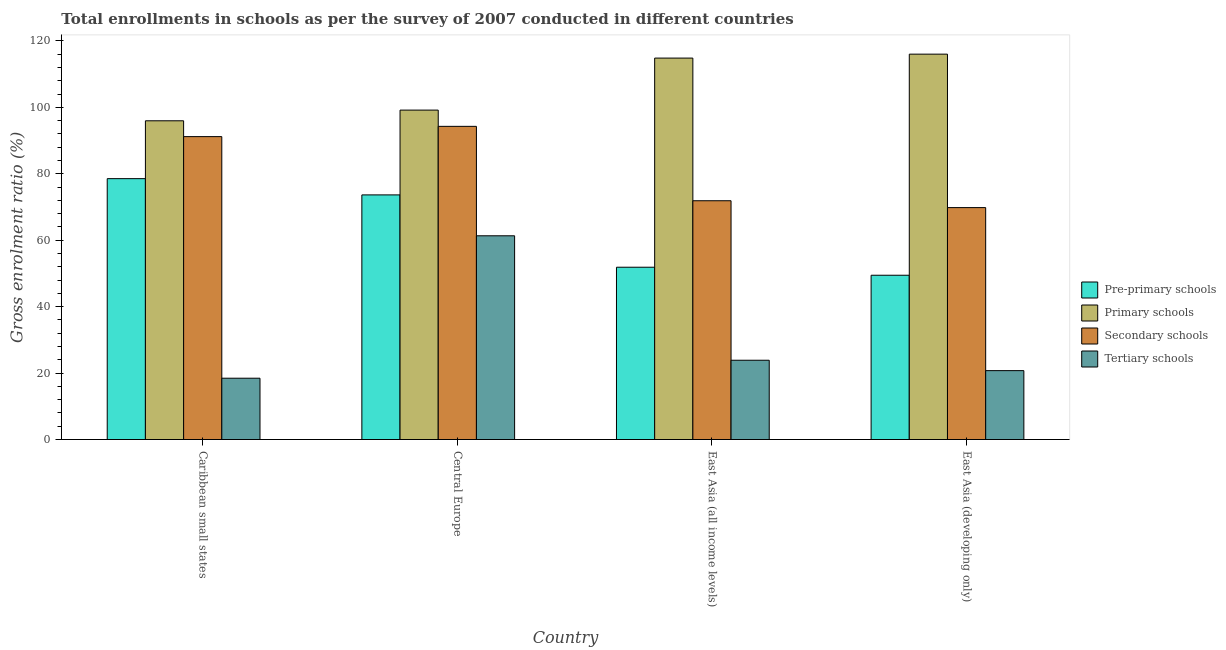How many groups of bars are there?
Ensure brevity in your answer.  4. How many bars are there on the 4th tick from the left?
Offer a terse response. 4. How many bars are there on the 2nd tick from the right?
Your answer should be compact. 4. What is the label of the 4th group of bars from the left?
Offer a terse response. East Asia (developing only). In how many cases, is the number of bars for a given country not equal to the number of legend labels?
Your answer should be very brief. 0. What is the gross enrolment ratio in primary schools in Central Europe?
Your answer should be compact. 99.16. Across all countries, what is the maximum gross enrolment ratio in secondary schools?
Make the answer very short. 94.27. Across all countries, what is the minimum gross enrolment ratio in tertiary schools?
Provide a short and direct response. 18.46. In which country was the gross enrolment ratio in pre-primary schools maximum?
Offer a very short reply. Caribbean small states. In which country was the gross enrolment ratio in pre-primary schools minimum?
Your answer should be compact. East Asia (developing only). What is the total gross enrolment ratio in secondary schools in the graph?
Give a very brief answer. 327.12. What is the difference between the gross enrolment ratio in secondary schools in Caribbean small states and that in East Asia (developing only)?
Provide a short and direct response. 21.37. What is the difference between the gross enrolment ratio in pre-primary schools in East Asia (developing only) and the gross enrolment ratio in tertiary schools in East Asia (all income levels)?
Give a very brief answer. 25.59. What is the average gross enrolment ratio in tertiary schools per country?
Ensure brevity in your answer.  31.1. What is the difference between the gross enrolment ratio in primary schools and gross enrolment ratio in pre-primary schools in Caribbean small states?
Your answer should be very brief. 17.41. In how many countries, is the gross enrolment ratio in secondary schools greater than 64 %?
Your answer should be very brief. 4. What is the ratio of the gross enrolment ratio in tertiary schools in Caribbean small states to that in East Asia (developing only)?
Offer a terse response. 0.89. What is the difference between the highest and the second highest gross enrolment ratio in secondary schools?
Provide a short and direct response. 3.09. What is the difference between the highest and the lowest gross enrolment ratio in primary schools?
Your answer should be very brief. 20.06. What does the 4th bar from the left in East Asia (developing only) represents?
Your response must be concise. Tertiary schools. What does the 4th bar from the right in East Asia (developing only) represents?
Provide a short and direct response. Pre-primary schools. How many bars are there?
Ensure brevity in your answer.  16. How many countries are there in the graph?
Provide a short and direct response. 4. Are the values on the major ticks of Y-axis written in scientific E-notation?
Offer a terse response. No. How many legend labels are there?
Your response must be concise. 4. What is the title of the graph?
Your answer should be compact. Total enrollments in schools as per the survey of 2007 conducted in different countries. What is the label or title of the X-axis?
Provide a succinct answer. Country. What is the label or title of the Y-axis?
Offer a very short reply. Gross enrolment ratio (%). What is the Gross enrolment ratio (%) in Pre-primary schools in Caribbean small states?
Give a very brief answer. 78.53. What is the Gross enrolment ratio (%) in Primary schools in Caribbean small states?
Give a very brief answer. 95.94. What is the Gross enrolment ratio (%) in Secondary schools in Caribbean small states?
Give a very brief answer. 91.18. What is the Gross enrolment ratio (%) of Tertiary schools in Caribbean small states?
Ensure brevity in your answer.  18.46. What is the Gross enrolment ratio (%) of Pre-primary schools in Central Europe?
Offer a very short reply. 73.64. What is the Gross enrolment ratio (%) in Primary schools in Central Europe?
Ensure brevity in your answer.  99.16. What is the Gross enrolment ratio (%) in Secondary schools in Central Europe?
Your answer should be very brief. 94.27. What is the Gross enrolment ratio (%) of Tertiary schools in Central Europe?
Ensure brevity in your answer.  61.33. What is the Gross enrolment ratio (%) of Pre-primary schools in East Asia (all income levels)?
Provide a short and direct response. 51.86. What is the Gross enrolment ratio (%) in Primary schools in East Asia (all income levels)?
Keep it short and to the point. 114.82. What is the Gross enrolment ratio (%) in Secondary schools in East Asia (all income levels)?
Offer a terse response. 71.87. What is the Gross enrolment ratio (%) in Tertiary schools in East Asia (all income levels)?
Your answer should be compact. 23.87. What is the Gross enrolment ratio (%) of Pre-primary schools in East Asia (developing only)?
Offer a terse response. 49.45. What is the Gross enrolment ratio (%) of Primary schools in East Asia (developing only)?
Offer a very short reply. 116. What is the Gross enrolment ratio (%) of Secondary schools in East Asia (developing only)?
Your response must be concise. 69.81. What is the Gross enrolment ratio (%) in Tertiary schools in East Asia (developing only)?
Provide a succinct answer. 20.74. Across all countries, what is the maximum Gross enrolment ratio (%) in Pre-primary schools?
Offer a terse response. 78.53. Across all countries, what is the maximum Gross enrolment ratio (%) in Primary schools?
Offer a very short reply. 116. Across all countries, what is the maximum Gross enrolment ratio (%) in Secondary schools?
Offer a very short reply. 94.27. Across all countries, what is the maximum Gross enrolment ratio (%) in Tertiary schools?
Give a very brief answer. 61.33. Across all countries, what is the minimum Gross enrolment ratio (%) of Pre-primary schools?
Offer a terse response. 49.45. Across all countries, what is the minimum Gross enrolment ratio (%) of Primary schools?
Provide a short and direct response. 95.94. Across all countries, what is the minimum Gross enrolment ratio (%) of Secondary schools?
Your answer should be very brief. 69.81. Across all countries, what is the minimum Gross enrolment ratio (%) in Tertiary schools?
Your response must be concise. 18.46. What is the total Gross enrolment ratio (%) of Pre-primary schools in the graph?
Keep it short and to the point. 253.47. What is the total Gross enrolment ratio (%) of Primary schools in the graph?
Make the answer very short. 425.92. What is the total Gross enrolment ratio (%) in Secondary schools in the graph?
Ensure brevity in your answer.  327.12. What is the total Gross enrolment ratio (%) in Tertiary schools in the graph?
Your answer should be very brief. 124.38. What is the difference between the Gross enrolment ratio (%) of Pre-primary schools in Caribbean small states and that in Central Europe?
Ensure brevity in your answer.  4.89. What is the difference between the Gross enrolment ratio (%) of Primary schools in Caribbean small states and that in Central Europe?
Keep it short and to the point. -3.22. What is the difference between the Gross enrolment ratio (%) of Secondary schools in Caribbean small states and that in Central Europe?
Your answer should be very brief. -3.09. What is the difference between the Gross enrolment ratio (%) of Tertiary schools in Caribbean small states and that in Central Europe?
Make the answer very short. -42.87. What is the difference between the Gross enrolment ratio (%) of Pre-primary schools in Caribbean small states and that in East Asia (all income levels)?
Give a very brief answer. 26.67. What is the difference between the Gross enrolment ratio (%) in Primary schools in Caribbean small states and that in East Asia (all income levels)?
Keep it short and to the point. -18.88. What is the difference between the Gross enrolment ratio (%) of Secondary schools in Caribbean small states and that in East Asia (all income levels)?
Your answer should be very brief. 19.3. What is the difference between the Gross enrolment ratio (%) of Tertiary schools in Caribbean small states and that in East Asia (all income levels)?
Provide a succinct answer. -5.41. What is the difference between the Gross enrolment ratio (%) of Pre-primary schools in Caribbean small states and that in East Asia (developing only)?
Provide a succinct answer. 29.08. What is the difference between the Gross enrolment ratio (%) in Primary schools in Caribbean small states and that in East Asia (developing only)?
Your answer should be compact. -20.06. What is the difference between the Gross enrolment ratio (%) in Secondary schools in Caribbean small states and that in East Asia (developing only)?
Give a very brief answer. 21.37. What is the difference between the Gross enrolment ratio (%) of Tertiary schools in Caribbean small states and that in East Asia (developing only)?
Provide a succinct answer. -2.28. What is the difference between the Gross enrolment ratio (%) in Pre-primary schools in Central Europe and that in East Asia (all income levels)?
Provide a short and direct response. 21.78. What is the difference between the Gross enrolment ratio (%) in Primary schools in Central Europe and that in East Asia (all income levels)?
Offer a terse response. -15.66. What is the difference between the Gross enrolment ratio (%) of Secondary schools in Central Europe and that in East Asia (all income levels)?
Provide a short and direct response. 22.39. What is the difference between the Gross enrolment ratio (%) of Tertiary schools in Central Europe and that in East Asia (all income levels)?
Give a very brief answer. 37.46. What is the difference between the Gross enrolment ratio (%) in Pre-primary schools in Central Europe and that in East Asia (developing only)?
Give a very brief answer. 24.19. What is the difference between the Gross enrolment ratio (%) of Primary schools in Central Europe and that in East Asia (developing only)?
Provide a succinct answer. -16.84. What is the difference between the Gross enrolment ratio (%) in Secondary schools in Central Europe and that in East Asia (developing only)?
Offer a very short reply. 24.46. What is the difference between the Gross enrolment ratio (%) in Tertiary schools in Central Europe and that in East Asia (developing only)?
Your answer should be very brief. 40.59. What is the difference between the Gross enrolment ratio (%) of Pre-primary schools in East Asia (all income levels) and that in East Asia (developing only)?
Ensure brevity in your answer.  2.41. What is the difference between the Gross enrolment ratio (%) in Primary schools in East Asia (all income levels) and that in East Asia (developing only)?
Ensure brevity in your answer.  -1.18. What is the difference between the Gross enrolment ratio (%) in Secondary schools in East Asia (all income levels) and that in East Asia (developing only)?
Offer a terse response. 2.06. What is the difference between the Gross enrolment ratio (%) in Tertiary schools in East Asia (all income levels) and that in East Asia (developing only)?
Keep it short and to the point. 3.13. What is the difference between the Gross enrolment ratio (%) of Pre-primary schools in Caribbean small states and the Gross enrolment ratio (%) of Primary schools in Central Europe?
Offer a very short reply. -20.63. What is the difference between the Gross enrolment ratio (%) in Pre-primary schools in Caribbean small states and the Gross enrolment ratio (%) in Secondary schools in Central Europe?
Provide a succinct answer. -15.74. What is the difference between the Gross enrolment ratio (%) of Pre-primary schools in Caribbean small states and the Gross enrolment ratio (%) of Tertiary schools in Central Europe?
Give a very brief answer. 17.2. What is the difference between the Gross enrolment ratio (%) of Primary schools in Caribbean small states and the Gross enrolment ratio (%) of Secondary schools in Central Europe?
Give a very brief answer. 1.67. What is the difference between the Gross enrolment ratio (%) of Primary schools in Caribbean small states and the Gross enrolment ratio (%) of Tertiary schools in Central Europe?
Provide a short and direct response. 34.61. What is the difference between the Gross enrolment ratio (%) of Secondary schools in Caribbean small states and the Gross enrolment ratio (%) of Tertiary schools in Central Europe?
Provide a short and direct response. 29.85. What is the difference between the Gross enrolment ratio (%) of Pre-primary schools in Caribbean small states and the Gross enrolment ratio (%) of Primary schools in East Asia (all income levels)?
Your answer should be very brief. -36.29. What is the difference between the Gross enrolment ratio (%) of Pre-primary schools in Caribbean small states and the Gross enrolment ratio (%) of Secondary schools in East Asia (all income levels)?
Your answer should be compact. 6.65. What is the difference between the Gross enrolment ratio (%) of Pre-primary schools in Caribbean small states and the Gross enrolment ratio (%) of Tertiary schools in East Asia (all income levels)?
Make the answer very short. 54.66. What is the difference between the Gross enrolment ratio (%) of Primary schools in Caribbean small states and the Gross enrolment ratio (%) of Secondary schools in East Asia (all income levels)?
Make the answer very short. 24.07. What is the difference between the Gross enrolment ratio (%) in Primary schools in Caribbean small states and the Gross enrolment ratio (%) in Tertiary schools in East Asia (all income levels)?
Provide a short and direct response. 72.08. What is the difference between the Gross enrolment ratio (%) in Secondary schools in Caribbean small states and the Gross enrolment ratio (%) in Tertiary schools in East Asia (all income levels)?
Offer a terse response. 67.31. What is the difference between the Gross enrolment ratio (%) of Pre-primary schools in Caribbean small states and the Gross enrolment ratio (%) of Primary schools in East Asia (developing only)?
Provide a succinct answer. -37.48. What is the difference between the Gross enrolment ratio (%) of Pre-primary schools in Caribbean small states and the Gross enrolment ratio (%) of Secondary schools in East Asia (developing only)?
Your response must be concise. 8.72. What is the difference between the Gross enrolment ratio (%) in Pre-primary schools in Caribbean small states and the Gross enrolment ratio (%) in Tertiary schools in East Asia (developing only)?
Your answer should be compact. 57.79. What is the difference between the Gross enrolment ratio (%) in Primary schools in Caribbean small states and the Gross enrolment ratio (%) in Secondary schools in East Asia (developing only)?
Make the answer very short. 26.13. What is the difference between the Gross enrolment ratio (%) in Primary schools in Caribbean small states and the Gross enrolment ratio (%) in Tertiary schools in East Asia (developing only)?
Provide a short and direct response. 75.2. What is the difference between the Gross enrolment ratio (%) of Secondary schools in Caribbean small states and the Gross enrolment ratio (%) of Tertiary schools in East Asia (developing only)?
Provide a short and direct response. 70.44. What is the difference between the Gross enrolment ratio (%) of Pre-primary schools in Central Europe and the Gross enrolment ratio (%) of Primary schools in East Asia (all income levels)?
Your response must be concise. -41.18. What is the difference between the Gross enrolment ratio (%) of Pre-primary schools in Central Europe and the Gross enrolment ratio (%) of Secondary schools in East Asia (all income levels)?
Provide a short and direct response. 1.76. What is the difference between the Gross enrolment ratio (%) in Pre-primary schools in Central Europe and the Gross enrolment ratio (%) in Tertiary schools in East Asia (all income levels)?
Ensure brevity in your answer.  49.77. What is the difference between the Gross enrolment ratio (%) in Primary schools in Central Europe and the Gross enrolment ratio (%) in Secondary schools in East Asia (all income levels)?
Make the answer very short. 27.29. What is the difference between the Gross enrolment ratio (%) of Primary schools in Central Europe and the Gross enrolment ratio (%) of Tertiary schools in East Asia (all income levels)?
Give a very brief answer. 75.3. What is the difference between the Gross enrolment ratio (%) of Secondary schools in Central Europe and the Gross enrolment ratio (%) of Tertiary schools in East Asia (all income levels)?
Your answer should be compact. 70.4. What is the difference between the Gross enrolment ratio (%) of Pre-primary schools in Central Europe and the Gross enrolment ratio (%) of Primary schools in East Asia (developing only)?
Provide a short and direct response. -42.37. What is the difference between the Gross enrolment ratio (%) of Pre-primary schools in Central Europe and the Gross enrolment ratio (%) of Secondary schools in East Asia (developing only)?
Keep it short and to the point. 3.83. What is the difference between the Gross enrolment ratio (%) of Pre-primary schools in Central Europe and the Gross enrolment ratio (%) of Tertiary schools in East Asia (developing only)?
Provide a succinct answer. 52.9. What is the difference between the Gross enrolment ratio (%) of Primary schools in Central Europe and the Gross enrolment ratio (%) of Secondary schools in East Asia (developing only)?
Provide a succinct answer. 29.35. What is the difference between the Gross enrolment ratio (%) in Primary schools in Central Europe and the Gross enrolment ratio (%) in Tertiary schools in East Asia (developing only)?
Offer a very short reply. 78.42. What is the difference between the Gross enrolment ratio (%) in Secondary schools in Central Europe and the Gross enrolment ratio (%) in Tertiary schools in East Asia (developing only)?
Offer a very short reply. 73.53. What is the difference between the Gross enrolment ratio (%) of Pre-primary schools in East Asia (all income levels) and the Gross enrolment ratio (%) of Primary schools in East Asia (developing only)?
Offer a terse response. -64.14. What is the difference between the Gross enrolment ratio (%) of Pre-primary schools in East Asia (all income levels) and the Gross enrolment ratio (%) of Secondary schools in East Asia (developing only)?
Provide a succinct answer. -17.95. What is the difference between the Gross enrolment ratio (%) in Pre-primary schools in East Asia (all income levels) and the Gross enrolment ratio (%) in Tertiary schools in East Asia (developing only)?
Offer a very short reply. 31.12. What is the difference between the Gross enrolment ratio (%) in Primary schools in East Asia (all income levels) and the Gross enrolment ratio (%) in Secondary schools in East Asia (developing only)?
Your answer should be compact. 45.01. What is the difference between the Gross enrolment ratio (%) of Primary schools in East Asia (all income levels) and the Gross enrolment ratio (%) of Tertiary schools in East Asia (developing only)?
Give a very brief answer. 94.08. What is the difference between the Gross enrolment ratio (%) in Secondary schools in East Asia (all income levels) and the Gross enrolment ratio (%) in Tertiary schools in East Asia (developing only)?
Provide a short and direct response. 51.14. What is the average Gross enrolment ratio (%) of Pre-primary schools per country?
Make the answer very short. 63.37. What is the average Gross enrolment ratio (%) of Primary schools per country?
Make the answer very short. 106.48. What is the average Gross enrolment ratio (%) of Secondary schools per country?
Make the answer very short. 81.78. What is the average Gross enrolment ratio (%) of Tertiary schools per country?
Make the answer very short. 31.1. What is the difference between the Gross enrolment ratio (%) in Pre-primary schools and Gross enrolment ratio (%) in Primary schools in Caribbean small states?
Provide a short and direct response. -17.41. What is the difference between the Gross enrolment ratio (%) in Pre-primary schools and Gross enrolment ratio (%) in Secondary schools in Caribbean small states?
Ensure brevity in your answer.  -12.65. What is the difference between the Gross enrolment ratio (%) of Pre-primary schools and Gross enrolment ratio (%) of Tertiary schools in Caribbean small states?
Your answer should be compact. 60.07. What is the difference between the Gross enrolment ratio (%) of Primary schools and Gross enrolment ratio (%) of Secondary schools in Caribbean small states?
Your response must be concise. 4.76. What is the difference between the Gross enrolment ratio (%) in Primary schools and Gross enrolment ratio (%) in Tertiary schools in Caribbean small states?
Make the answer very short. 77.48. What is the difference between the Gross enrolment ratio (%) in Secondary schools and Gross enrolment ratio (%) in Tertiary schools in Caribbean small states?
Ensure brevity in your answer.  72.72. What is the difference between the Gross enrolment ratio (%) in Pre-primary schools and Gross enrolment ratio (%) in Primary schools in Central Europe?
Your answer should be compact. -25.52. What is the difference between the Gross enrolment ratio (%) in Pre-primary schools and Gross enrolment ratio (%) in Secondary schools in Central Europe?
Make the answer very short. -20.63. What is the difference between the Gross enrolment ratio (%) of Pre-primary schools and Gross enrolment ratio (%) of Tertiary schools in Central Europe?
Provide a short and direct response. 12.31. What is the difference between the Gross enrolment ratio (%) of Primary schools and Gross enrolment ratio (%) of Secondary schools in Central Europe?
Make the answer very short. 4.89. What is the difference between the Gross enrolment ratio (%) of Primary schools and Gross enrolment ratio (%) of Tertiary schools in Central Europe?
Offer a very short reply. 37.83. What is the difference between the Gross enrolment ratio (%) in Secondary schools and Gross enrolment ratio (%) in Tertiary schools in Central Europe?
Provide a short and direct response. 32.94. What is the difference between the Gross enrolment ratio (%) in Pre-primary schools and Gross enrolment ratio (%) in Primary schools in East Asia (all income levels)?
Keep it short and to the point. -62.96. What is the difference between the Gross enrolment ratio (%) of Pre-primary schools and Gross enrolment ratio (%) of Secondary schools in East Asia (all income levels)?
Give a very brief answer. -20.01. What is the difference between the Gross enrolment ratio (%) of Pre-primary schools and Gross enrolment ratio (%) of Tertiary schools in East Asia (all income levels)?
Make the answer very short. 28. What is the difference between the Gross enrolment ratio (%) in Primary schools and Gross enrolment ratio (%) in Secondary schools in East Asia (all income levels)?
Provide a succinct answer. 42.95. What is the difference between the Gross enrolment ratio (%) of Primary schools and Gross enrolment ratio (%) of Tertiary schools in East Asia (all income levels)?
Offer a very short reply. 90.95. What is the difference between the Gross enrolment ratio (%) of Secondary schools and Gross enrolment ratio (%) of Tertiary schools in East Asia (all income levels)?
Your answer should be very brief. 48.01. What is the difference between the Gross enrolment ratio (%) of Pre-primary schools and Gross enrolment ratio (%) of Primary schools in East Asia (developing only)?
Your response must be concise. -66.55. What is the difference between the Gross enrolment ratio (%) in Pre-primary schools and Gross enrolment ratio (%) in Secondary schools in East Asia (developing only)?
Offer a very short reply. -20.36. What is the difference between the Gross enrolment ratio (%) of Pre-primary schools and Gross enrolment ratio (%) of Tertiary schools in East Asia (developing only)?
Provide a succinct answer. 28.71. What is the difference between the Gross enrolment ratio (%) of Primary schools and Gross enrolment ratio (%) of Secondary schools in East Asia (developing only)?
Make the answer very short. 46.19. What is the difference between the Gross enrolment ratio (%) in Primary schools and Gross enrolment ratio (%) in Tertiary schools in East Asia (developing only)?
Your response must be concise. 95.27. What is the difference between the Gross enrolment ratio (%) of Secondary schools and Gross enrolment ratio (%) of Tertiary schools in East Asia (developing only)?
Give a very brief answer. 49.07. What is the ratio of the Gross enrolment ratio (%) in Pre-primary schools in Caribbean small states to that in Central Europe?
Keep it short and to the point. 1.07. What is the ratio of the Gross enrolment ratio (%) in Primary schools in Caribbean small states to that in Central Europe?
Offer a terse response. 0.97. What is the ratio of the Gross enrolment ratio (%) of Secondary schools in Caribbean small states to that in Central Europe?
Keep it short and to the point. 0.97. What is the ratio of the Gross enrolment ratio (%) of Tertiary schools in Caribbean small states to that in Central Europe?
Your response must be concise. 0.3. What is the ratio of the Gross enrolment ratio (%) in Pre-primary schools in Caribbean small states to that in East Asia (all income levels)?
Provide a short and direct response. 1.51. What is the ratio of the Gross enrolment ratio (%) in Primary schools in Caribbean small states to that in East Asia (all income levels)?
Offer a terse response. 0.84. What is the ratio of the Gross enrolment ratio (%) of Secondary schools in Caribbean small states to that in East Asia (all income levels)?
Keep it short and to the point. 1.27. What is the ratio of the Gross enrolment ratio (%) of Tertiary schools in Caribbean small states to that in East Asia (all income levels)?
Give a very brief answer. 0.77. What is the ratio of the Gross enrolment ratio (%) of Pre-primary schools in Caribbean small states to that in East Asia (developing only)?
Offer a terse response. 1.59. What is the ratio of the Gross enrolment ratio (%) in Primary schools in Caribbean small states to that in East Asia (developing only)?
Make the answer very short. 0.83. What is the ratio of the Gross enrolment ratio (%) in Secondary schools in Caribbean small states to that in East Asia (developing only)?
Offer a terse response. 1.31. What is the ratio of the Gross enrolment ratio (%) in Tertiary schools in Caribbean small states to that in East Asia (developing only)?
Offer a very short reply. 0.89. What is the ratio of the Gross enrolment ratio (%) of Pre-primary schools in Central Europe to that in East Asia (all income levels)?
Keep it short and to the point. 1.42. What is the ratio of the Gross enrolment ratio (%) of Primary schools in Central Europe to that in East Asia (all income levels)?
Make the answer very short. 0.86. What is the ratio of the Gross enrolment ratio (%) in Secondary schools in Central Europe to that in East Asia (all income levels)?
Your answer should be compact. 1.31. What is the ratio of the Gross enrolment ratio (%) of Tertiary schools in Central Europe to that in East Asia (all income levels)?
Keep it short and to the point. 2.57. What is the ratio of the Gross enrolment ratio (%) in Pre-primary schools in Central Europe to that in East Asia (developing only)?
Your answer should be very brief. 1.49. What is the ratio of the Gross enrolment ratio (%) of Primary schools in Central Europe to that in East Asia (developing only)?
Offer a very short reply. 0.85. What is the ratio of the Gross enrolment ratio (%) in Secondary schools in Central Europe to that in East Asia (developing only)?
Your answer should be very brief. 1.35. What is the ratio of the Gross enrolment ratio (%) in Tertiary schools in Central Europe to that in East Asia (developing only)?
Offer a very short reply. 2.96. What is the ratio of the Gross enrolment ratio (%) of Pre-primary schools in East Asia (all income levels) to that in East Asia (developing only)?
Keep it short and to the point. 1.05. What is the ratio of the Gross enrolment ratio (%) of Secondary schools in East Asia (all income levels) to that in East Asia (developing only)?
Your answer should be very brief. 1.03. What is the ratio of the Gross enrolment ratio (%) of Tertiary schools in East Asia (all income levels) to that in East Asia (developing only)?
Offer a very short reply. 1.15. What is the difference between the highest and the second highest Gross enrolment ratio (%) of Pre-primary schools?
Provide a succinct answer. 4.89. What is the difference between the highest and the second highest Gross enrolment ratio (%) of Primary schools?
Keep it short and to the point. 1.18. What is the difference between the highest and the second highest Gross enrolment ratio (%) in Secondary schools?
Provide a short and direct response. 3.09. What is the difference between the highest and the second highest Gross enrolment ratio (%) of Tertiary schools?
Keep it short and to the point. 37.46. What is the difference between the highest and the lowest Gross enrolment ratio (%) in Pre-primary schools?
Give a very brief answer. 29.08. What is the difference between the highest and the lowest Gross enrolment ratio (%) of Primary schools?
Keep it short and to the point. 20.06. What is the difference between the highest and the lowest Gross enrolment ratio (%) in Secondary schools?
Make the answer very short. 24.46. What is the difference between the highest and the lowest Gross enrolment ratio (%) in Tertiary schools?
Your answer should be very brief. 42.87. 